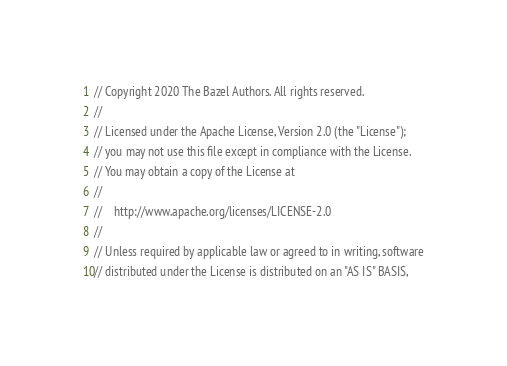<code> <loc_0><loc_0><loc_500><loc_500><_Java_>// Copyright 2020 The Bazel Authors. All rights reserved.
//
// Licensed under the Apache License, Version 2.0 (the "License");
// you may not use this file except in compliance with the License.
// You may obtain a copy of the License at
//
//    http://www.apache.org/licenses/LICENSE-2.0
//
// Unless required by applicable law or agreed to in writing, software
// distributed under the License is distributed on an "AS IS" BASIS,</code> 